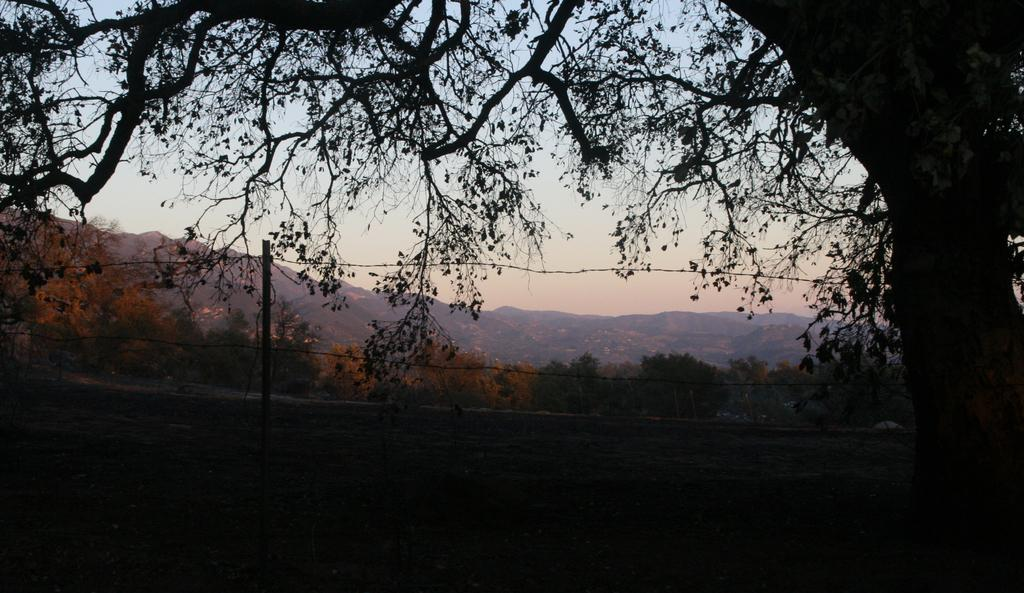What type of natural feature is present in the image? There is a tree in the image. What part of the tree is visible? The bark of the tree is visible. What man-made object is present in the image? There is a pole in the image. What is attached to the pole? Wires are present in the image. What type of landscape can be seen in the background? There are mountains visible in the background. How would you describe the sky in the image? The sky is visible and appears cloudy. What flavor of ice cream is being served at the tree in the image? There is no ice cream present in the image, and the tree is not serving any food or beverages. 